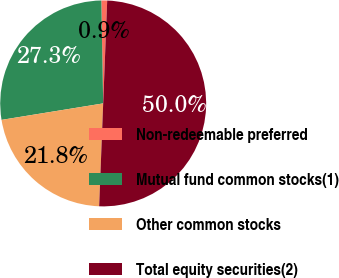Convert chart to OTSL. <chart><loc_0><loc_0><loc_500><loc_500><pie_chart><fcel>Non-redeemable preferred<fcel>Mutual fund common stocks(1)<fcel>Other common stocks<fcel>Total equity securities(2)<nl><fcel>0.91%<fcel>27.27%<fcel>21.82%<fcel>50.0%<nl></chart> 